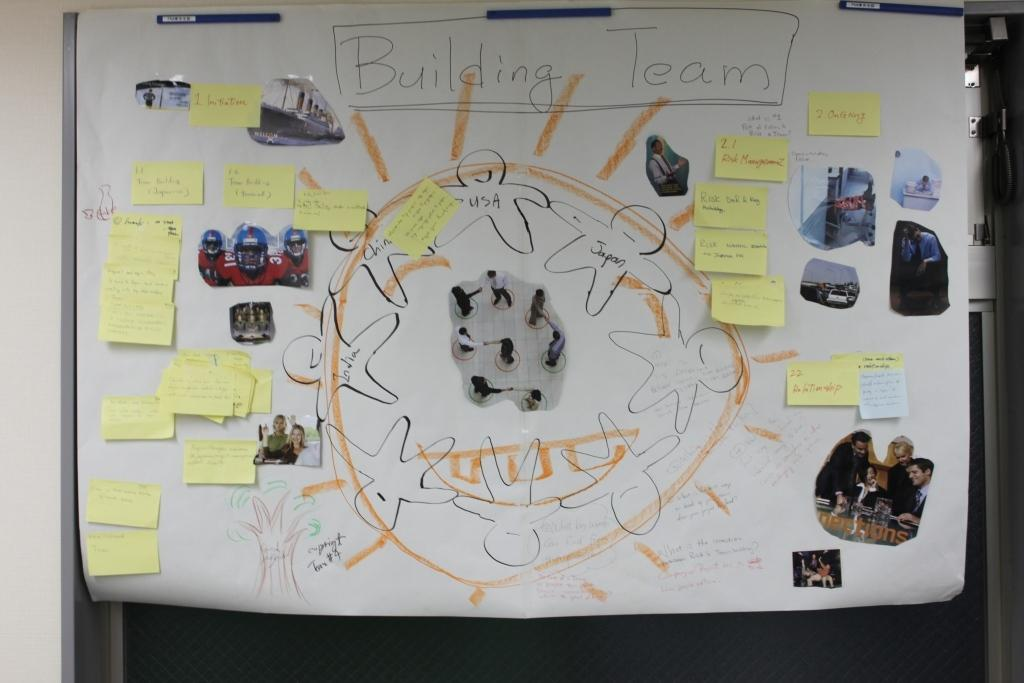What is the main object in the image? There is a white chart poster in the image. Are there any additional elements attached to the chart poster? Yes, there are some yellow color sticky notes attached to the chart poster. What else can be seen on the chart poster? There are photographs attached to the chart. What season is depicted in the image? There is no season depicted in the image; it is a chart poster with sticky notes and photographs. Is there a letter addressed to someone in the image? There is no letter present in the image. 